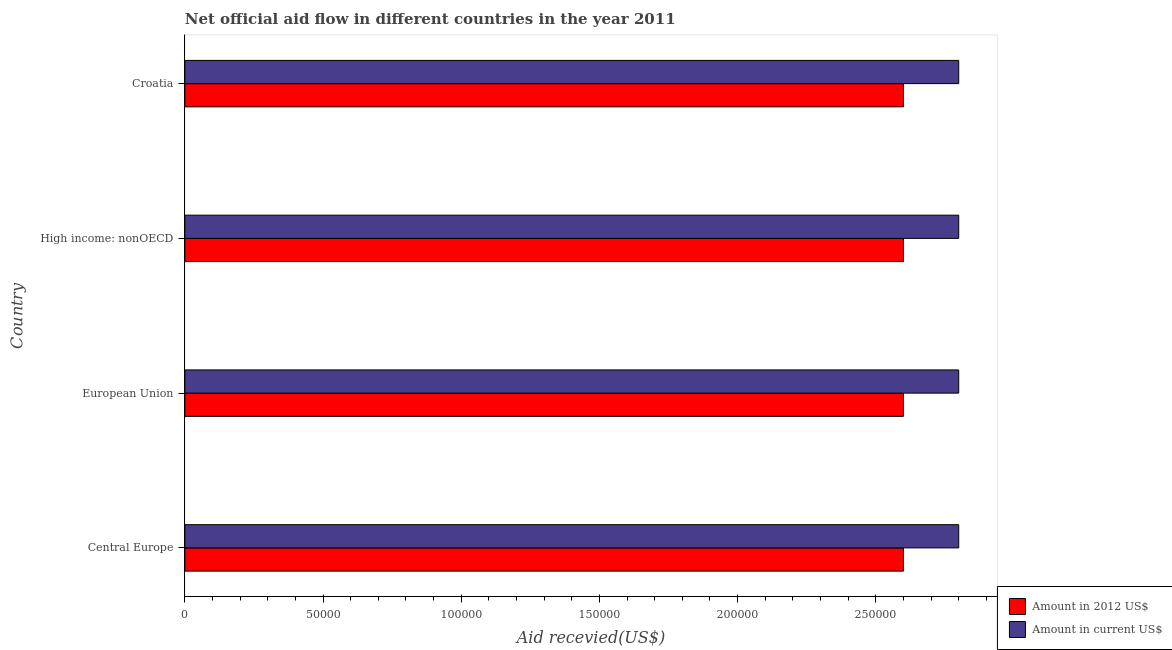Are the number of bars per tick equal to the number of legend labels?
Offer a terse response. Yes. How many bars are there on the 1st tick from the top?
Offer a very short reply. 2. What is the label of the 1st group of bars from the top?
Offer a very short reply. Croatia. In how many cases, is the number of bars for a given country not equal to the number of legend labels?
Give a very brief answer. 0. What is the amount of aid received(expressed in us$) in High income: nonOECD?
Your answer should be very brief. 2.80e+05. Across all countries, what is the maximum amount of aid received(expressed in 2012 us$)?
Keep it short and to the point. 2.60e+05. Across all countries, what is the minimum amount of aid received(expressed in 2012 us$)?
Keep it short and to the point. 2.60e+05. In which country was the amount of aid received(expressed in 2012 us$) maximum?
Give a very brief answer. Central Europe. In which country was the amount of aid received(expressed in 2012 us$) minimum?
Provide a short and direct response. Central Europe. What is the total amount of aid received(expressed in 2012 us$) in the graph?
Offer a terse response. 1.04e+06. What is the difference between the amount of aid received(expressed in us$) in Croatia and that in European Union?
Your answer should be compact. 0. What is the difference between the amount of aid received(expressed in us$) in Central Europe and the amount of aid received(expressed in 2012 us$) in European Union?
Provide a short and direct response. 2.00e+04. What is the difference between the amount of aid received(expressed in 2012 us$) and amount of aid received(expressed in us$) in High income: nonOECD?
Keep it short and to the point. -2.00e+04. What is the difference between the highest and the second highest amount of aid received(expressed in 2012 us$)?
Your response must be concise. 0. What is the difference between the highest and the lowest amount of aid received(expressed in us$)?
Ensure brevity in your answer.  0. In how many countries, is the amount of aid received(expressed in 2012 us$) greater than the average amount of aid received(expressed in 2012 us$) taken over all countries?
Provide a succinct answer. 0. What does the 1st bar from the top in Central Europe represents?
Provide a short and direct response. Amount in current US$. What does the 2nd bar from the bottom in Croatia represents?
Your answer should be compact. Amount in current US$. Are all the bars in the graph horizontal?
Your answer should be very brief. Yes. What is the difference between two consecutive major ticks on the X-axis?
Give a very brief answer. 5.00e+04. Are the values on the major ticks of X-axis written in scientific E-notation?
Your response must be concise. No. Where does the legend appear in the graph?
Provide a succinct answer. Bottom right. How many legend labels are there?
Offer a terse response. 2. How are the legend labels stacked?
Your response must be concise. Vertical. What is the title of the graph?
Your answer should be compact. Net official aid flow in different countries in the year 2011. What is the label or title of the X-axis?
Ensure brevity in your answer.  Aid recevied(US$). What is the label or title of the Y-axis?
Offer a terse response. Country. What is the Aid recevied(US$) in Amount in 2012 US$ in Central Europe?
Give a very brief answer. 2.60e+05. What is the Aid recevied(US$) of Amount in current US$ in Central Europe?
Your response must be concise. 2.80e+05. What is the Aid recevied(US$) in Amount in current US$ in European Union?
Provide a succinct answer. 2.80e+05. What is the Aid recevied(US$) in Amount in 2012 US$ in High income: nonOECD?
Ensure brevity in your answer.  2.60e+05. What is the Aid recevied(US$) in Amount in 2012 US$ in Croatia?
Provide a short and direct response. 2.60e+05. Across all countries, what is the maximum Aid recevied(US$) of Amount in 2012 US$?
Your answer should be compact. 2.60e+05. Across all countries, what is the minimum Aid recevied(US$) in Amount in 2012 US$?
Your response must be concise. 2.60e+05. Across all countries, what is the minimum Aid recevied(US$) of Amount in current US$?
Your response must be concise. 2.80e+05. What is the total Aid recevied(US$) in Amount in 2012 US$ in the graph?
Offer a terse response. 1.04e+06. What is the total Aid recevied(US$) of Amount in current US$ in the graph?
Your answer should be very brief. 1.12e+06. What is the difference between the Aid recevied(US$) in Amount in current US$ in Central Europe and that in European Union?
Your answer should be compact. 0. What is the difference between the Aid recevied(US$) in Amount in 2012 US$ in Central Europe and that in High income: nonOECD?
Keep it short and to the point. 0. What is the difference between the Aid recevied(US$) in Amount in current US$ in Central Europe and that in High income: nonOECD?
Give a very brief answer. 0. What is the difference between the Aid recevied(US$) of Amount in 2012 US$ in Central Europe and that in Croatia?
Your answer should be compact. 0. What is the difference between the Aid recevied(US$) of Amount in 2012 US$ in European Union and that in High income: nonOECD?
Provide a succinct answer. 0. What is the difference between the Aid recevied(US$) in Amount in 2012 US$ in European Union and that in Croatia?
Make the answer very short. 0. What is the difference between the Aid recevied(US$) in Amount in 2012 US$ in High income: nonOECD and that in Croatia?
Provide a succinct answer. 0. What is the difference between the Aid recevied(US$) in Amount in current US$ in High income: nonOECD and that in Croatia?
Offer a terse response. 0. What is the difference between the Aid recevied(US$) of Amount in 2012 US$ in High income: nonOECD and the Aid recevied(US$) of Amount in current US$ in Croatia?
Give a very brief answer. -2.00e+04. What is the average Aid recevied(US$) of Amount in 2012 US$ per country?
Provide a short and direct response. 2.60e+05. What is the average Aid recevied(US$) of Amount in current US$ per country?
Give a very brief answer. 2.80e+05. What is the difference between the Aid recevied(US$) of Amount in 2012 US$ and Aid recevied(US$) of Amount in current US$ in High income: nonOECD?
Offer a terse response. -2.00e+04. What is the ratio of the Aid recevied(US$) of Amount in 2012 US$ in Central Europe to that in European Union?
Make the answer very short. 1. What is the ratio of the Aid recevied(US$) of Amount in 2012 US$ in Central Europe to that in High income: nonOECD?
Offer a very short reply. 1. What is the ratio of the Aid recevied(US$) in Amount in current US$ in Central Europe to that in High income: nonOECD?
Give a very brief answer. 1. What is the ratio of the Aid recevied(US$) in Amount in 2012 US$ in Central Europe to that in Croatia?
Ensure brevity in your answer.  1. What is the ratio of the Aid recevied(US$) of Amount in current US$ in Central Europe to that in Croatia?
Offer a terse response. 1. What is the ratio of the Aid recevied(US$) in Amount in current US$ in European Union to that in High income: nonOECD?
Your answer should be very brief. 1. What is the ratio of the Aid recevied(US$) of Amount in 2012 US$ in European Union to that in Croatia?
Ensure brevity in your answer.  1. What is the ratio of the Aid recevied(US$) of Amount in current US$ in European Union to that in Croatia?
Provide a succinct answer. 1. What is the difference between the highest and the lowest Aid recevied(US$) in Amount in 2012 US$?
Offer a terse response. 0. 